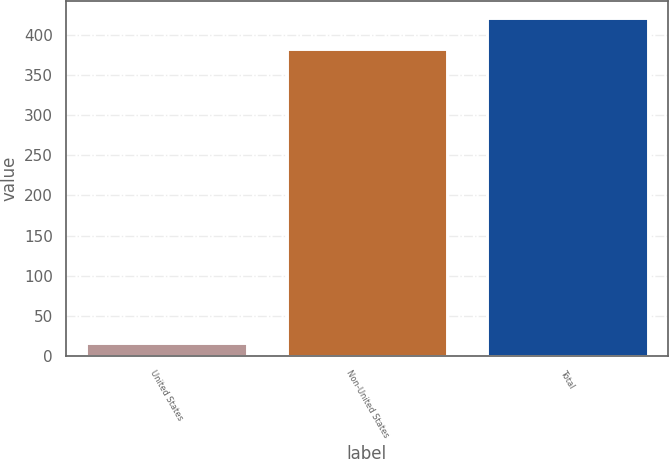Convert chart. <chart><loc_0><loc_0><loc_500><loc_500><bar_chart><fcel>United States<fcel>Non-United States<fcel>Total<nl><fcel>15.7<fcel>383.3<fcel>421.63<nl></chart> 